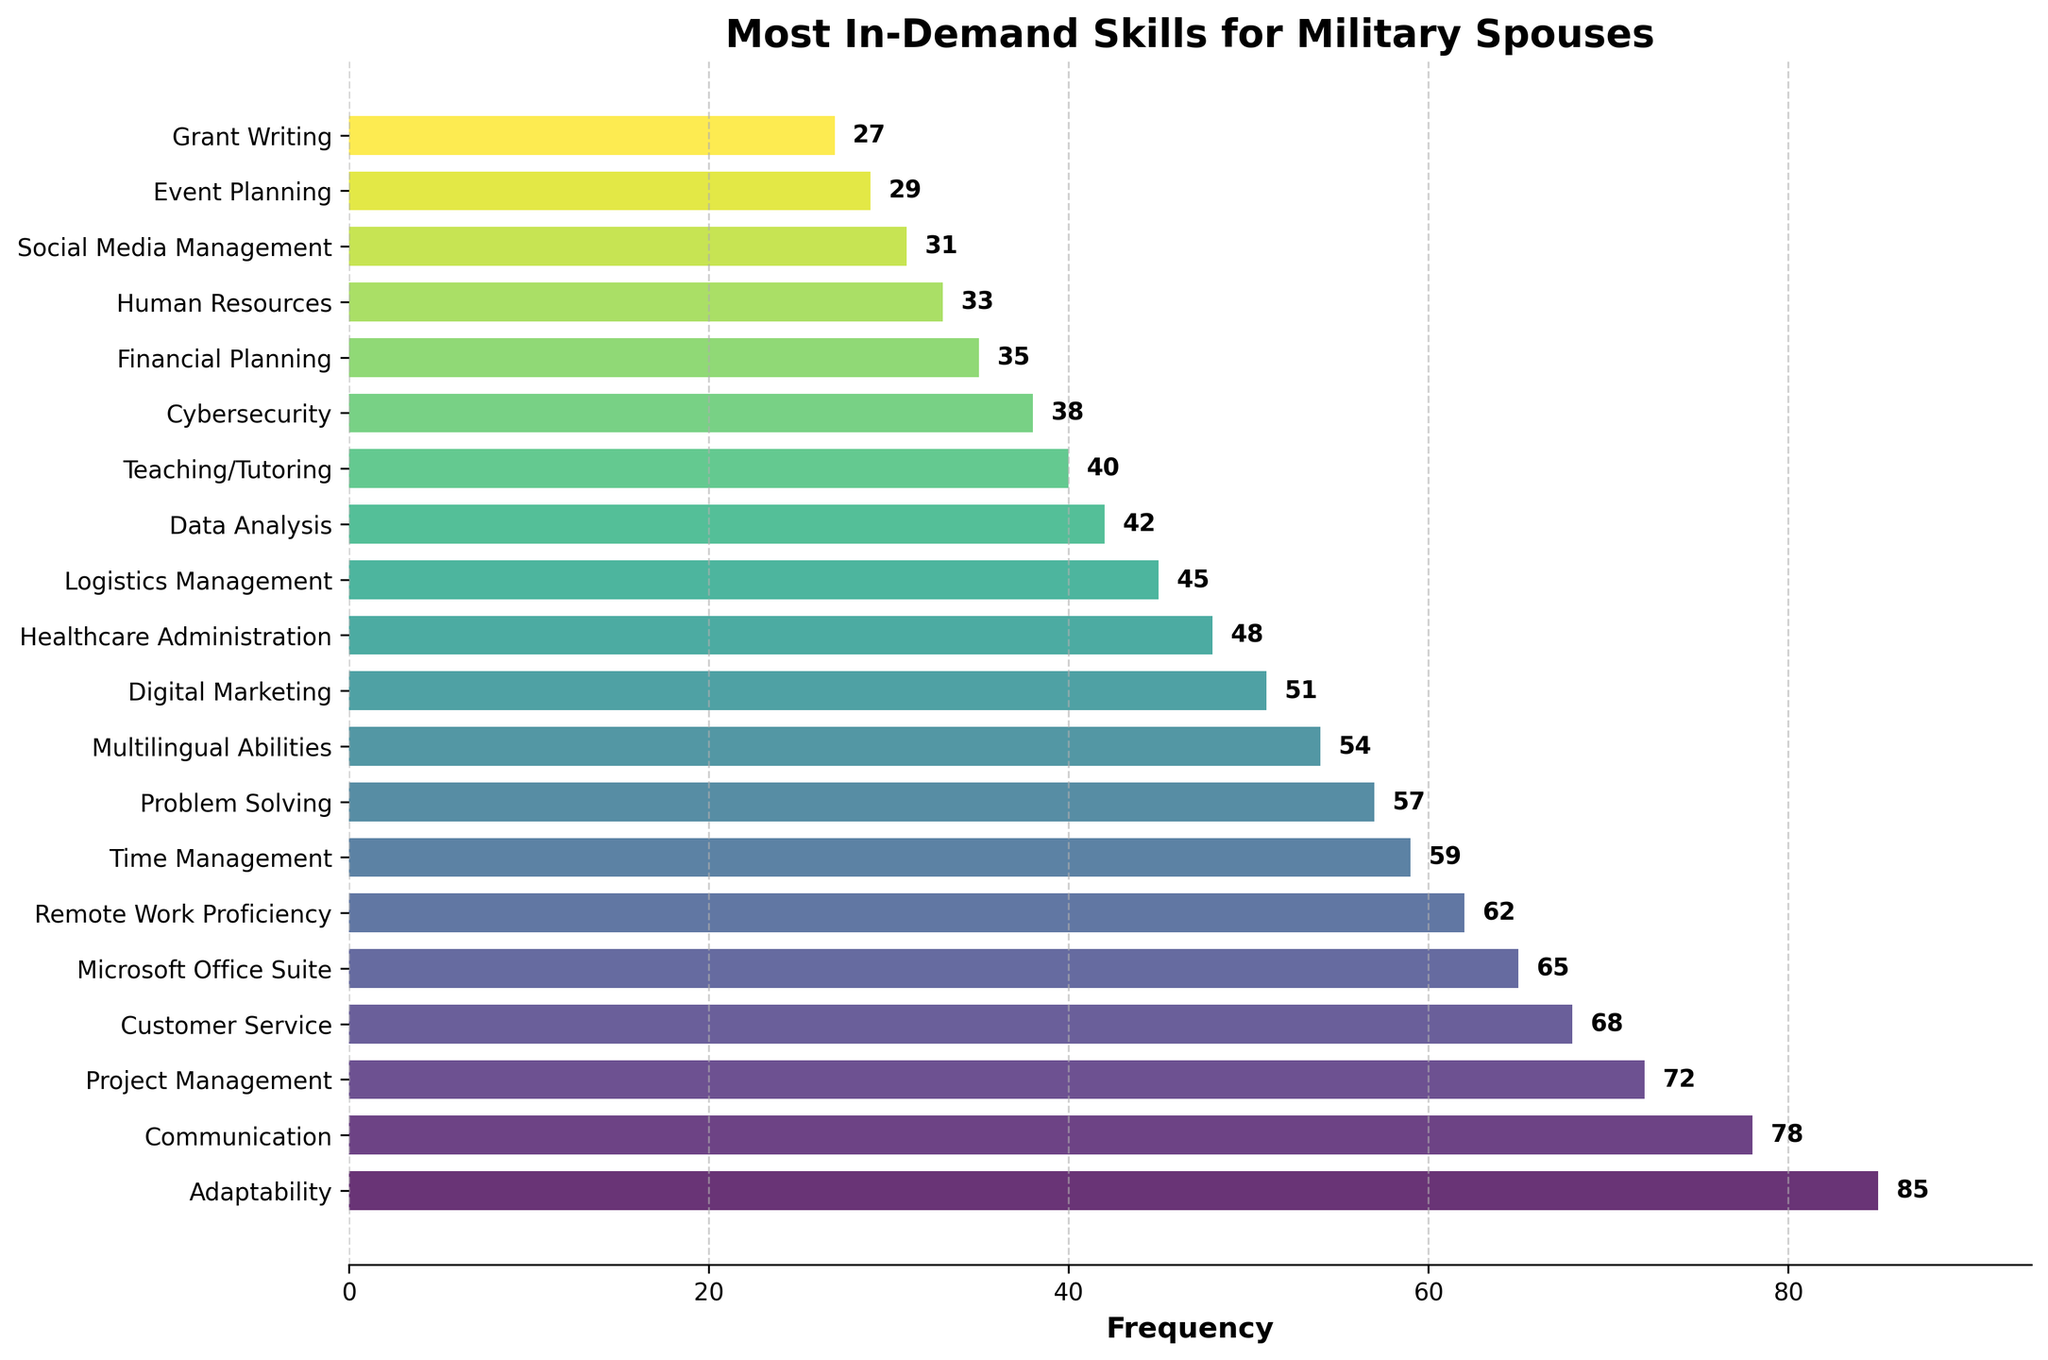Which skill has the highest frequency? The bar at the top represents the skill with the highest frequency. The length of the bar and the attached label indicate the frequency.
Answer: Adaptability What's the difference in frequency between Adaptability and Digital Marketing? Adaptability has a frequency of 85, and Digital Marketing has a frequency of 51. The difference is 85 - 51.
Answer: 34 Which skills have a higher frequency than Remote Work Proficiency but lower than Project Management? To identify the skills, look at the bars with frequencies greater than 62 (Remote Work Proficiency) and less than 72 (Project Management).
Answer: Customer Service and Microsoft Office Suite What's the median frequency of the top 5 most in-demand skills? The top 5 skills in frequency are Adaptability (85), Communication (78), Project Management (72), Customer Service (68), and Microsoft Office Suite (65). The median value is the middle number when they are sorted: 68.
Answer: 68 Which skill is depicted with the shortest bar? The shortest bar represents the skill with the lowest frequency, which can be seen by looking at the bottom of the plot.
Answer: Grant Writing How many skills have a frequency above 50? Count the bars that have their frequency values labeled above 50.
Answer: 10 What is the frequency range (difference between highest and lowest frequency) of the listed skills? The highest frequency is 85 (Adaptability) and the lowest is 27 (Grant Writing). The range is 85 - 27.
Answer: 58 How does the length of the bar for Teaching/Tutoring compare to that of Logistics Management? Compare the length of the bars directly. Teaching/Tutoring has a frequency of 40, while Logistics Management has a frequency of 45. Teaching/Tutoring has a shorter bar.
Answer: Shorter If you combine the frequencies of Adaptability and Communication, how does the sum compare to the total frequency of Project Management and Data Analysis? Sum the frequencies of each pair: Adaptability + Communication = 85 + 78 = 163, Project Management + Data Analysis = 72 + 42 = 114. Compare the sums.
Answer: Sum is higher for Adaptability and Communication Which skills are tied in frequency and what is that frequency? Look for bars with equal length, indicating the same frequency.
Answer: There are no ties in the frequency 